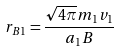<formula> <loc_0><loc_0><loc_500><loc_500>r _ { B 1 } = { \frac { { \sqrt { 4 \pi } } m _ { 1 } v _ { 1 } } { a _ { 1 } B } }</formula> 